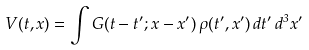Convert formula to latex. <formula><loc_0><loc_0><loc_500><loc_500>V ( t , x ) = \int G ( t - t ^ { \prime } ; x - x ^ { \prime } ) \, \rho ( t ^ { \prime } , x ^ { \prime } ) \, d t ^ { \prime } \, d ^ { 3 } x ^ { \prime }</formula> 